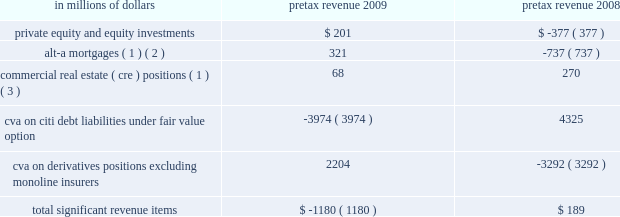2009 vs .
2008 revenues , net of interest expense increased 11% ( 11 % ) or $ 2.7 billion , as markets began to recover in the early part of 2009 , bringing back higher levels of volume activity and higher levels of liquidity , which began to decline again in the third quarter of 2009 .
The growth in revenue in the early part of the year was mainly due to a $ 7.1 billion increase in fixed income markets , reflecting strong trading opportunities across all asset classes in the first half of 2009 , and a $ 1.5 billion increase in investment banking revenue primarily from increases in debt and equity underwriting activities reflecting higher transaction volumes from depressed 2008 levels .
These increases were offset by a $ 6.4 billion decrease in lending revenue primarily from losses on credit default swap hedges .
Excluding the 2009 and 2008 cva impact , as indicated in the table below , revenues increased 23% ( 23 % ) or $ 5.5 billion .
Operating expenses decreased 17% ( 17 % ) , or $ 2.7 billion .
Excluding the 2008 repositioning and restructuring charges and the 2009 litigation reserve release , operating expenses declined 11% ( 11 % ) or $ 1.6 billion , mainly as a result of headcount reductions and benefits from expense management .
Provisions for loan losses and for benefits and claims decreased 7% ( 7 % ) or $ 129 million , to $ 1.7 billion , mainly due to lower credit reserve builds and net credit losses , due to an improved credit environment , particularly in the latter part of the year .
2008 vs .
2007 revenues , net of interest expense decreased 2% ( 2 % ) or $ 0.4 billion reflecting the overall difficult market conditions .
Excluding the 2008 and 2007 cva impact , revenues decreased 3% ( 3 % ) or $ 0.6 billion .
The reduction in revenue was primarily due to a decrease in investment banking revenue of $ 2.3 billion to $ 3.2 billion , mainly in debt and equity underwriting , reflecting lower volumes , and a decrease in equity markets revenue of $ 2.3 billion to $ 2.9 billion due to extremely high volatility and reduced levels of activity .
These reductions were offset by an increase in fixed income markets of $ 2.9 billion to $ 14.4 billion due to strong performance in interest rates and currencies , and an increase in lending revenue of $ 2.4 billion to $ 4.2 billion mainly from gains on credit default swap hedges .
Operating expenses decreased by 2% ( 2 % ) or $ 0.4 billion .
Excluding the 2008 and 2007 repositioning and restructuring charges and the 2007 litigation reserve reversal , operating expenses decreased by 7% ( 7 % ) or $ 1.1 billion driven by headcount reduction and lower performance-based incentives .
Provisions for credit losses and for benefits and claims increased $ 1.3 billion to $ 1.8 billion mainly from higher credit reserve builds and net credit losses offset by a lower provision for unfunded lending commitments due to deterioration in the credit environment .
Certain revenues impacting securities and banking items that impacted s&b revenues during 2009 and 2008 are set forth in the table below. .
( 1 ) net of hedges .
( 2 ) for these purposes , alt-a mortgage securities are non-agency residential mortgage-backed securities ( rmbs ) where ( i ) the underlying collateral has weighted average fico scores between 680 and 720 or ( ii ) for instances where fico scores are greater than 720 , rmbs have 30% ( 30 % ) or less of the underlying collateral composed of full documentation loans .
See 201cmanaging global risk 2014credit risk 2014u.s .
Consumer mortgage lending . 201d ( 3 ) s&b 2019s commercial real estate exposure is split into three categories of assets : held at fair value ; held- to-maturity/held-for-investment ; and equity .
See 201cmanaging global risk 2014credit risk 2014exposure to commercial real estate 201d section for a further discussion .
In the table above , 2009 includes a $ 330 million pretax adjustment to the cva balance , which reduced pretax revenues for the year , reflecting a correction of an error related to prior periods .
See 201csignificant accounting policies and significant estimates 201d below and notes 1 and 34 to the consolidated financial statements for a further discussion of this adjustment .
2010 outlook the 2010 outlook for s&b will depend on the level of client activity and on macroeconomic conditions , market valuations and volatility , interest rates and other market factors .
Management of s&b currently expects to maintain client activity throughout 2010 and to operate in market conditions that offer moderate volatility and increased liquidity .
Operating expenses will benefit from continued re-engineering and expense management initiatives , but will be offset by investments in talent and infrastructure to support growth. .
What was the change in millions of alt-a mortgages pretax revenue from 2008 to 2009? 
Computations: (321 - -737)
Answer: 1058.0. 